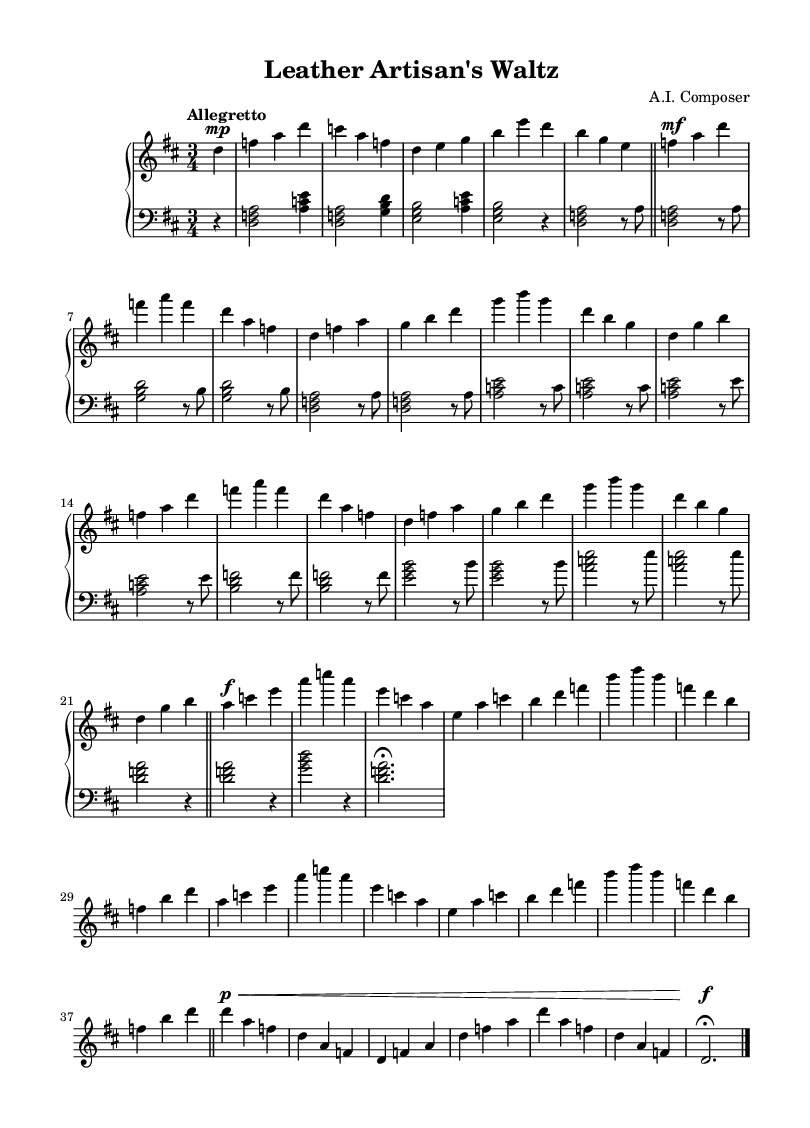What is the key signature of this music? The key signature is D major, which has two sharps: F# and C#.
Answer: D major What is the time signature of the piece? The time signature is three beats per measure, which is indicated as 3/4.
Answer: 3/4 What is the tempo marking for this composition? The tempo marking is "Allegretto," indicating a moderately fast pace.
Answer: Allegretto How many sections does the piece contain? The piece has three main sections labeled A, B, and a coda at the end, which indicates structural variation.
Answer: Three Which section features the dynamic markings "f" (forte) and "p" (piano)? The B section features multiple instances of "f" and the coda introduces "p" indicating a softer return.
Answer: B Section, Coda What is the highest note in the upper staff? The highest note in the upper staff is B in the last measure of the A section, which is the peak of the melodic line.
Answer: B How is the piece concluded? The piece concludes with a fermata over a D note followed by a double bar line, indicating the end of the composition.
Answer: Fermata on D 